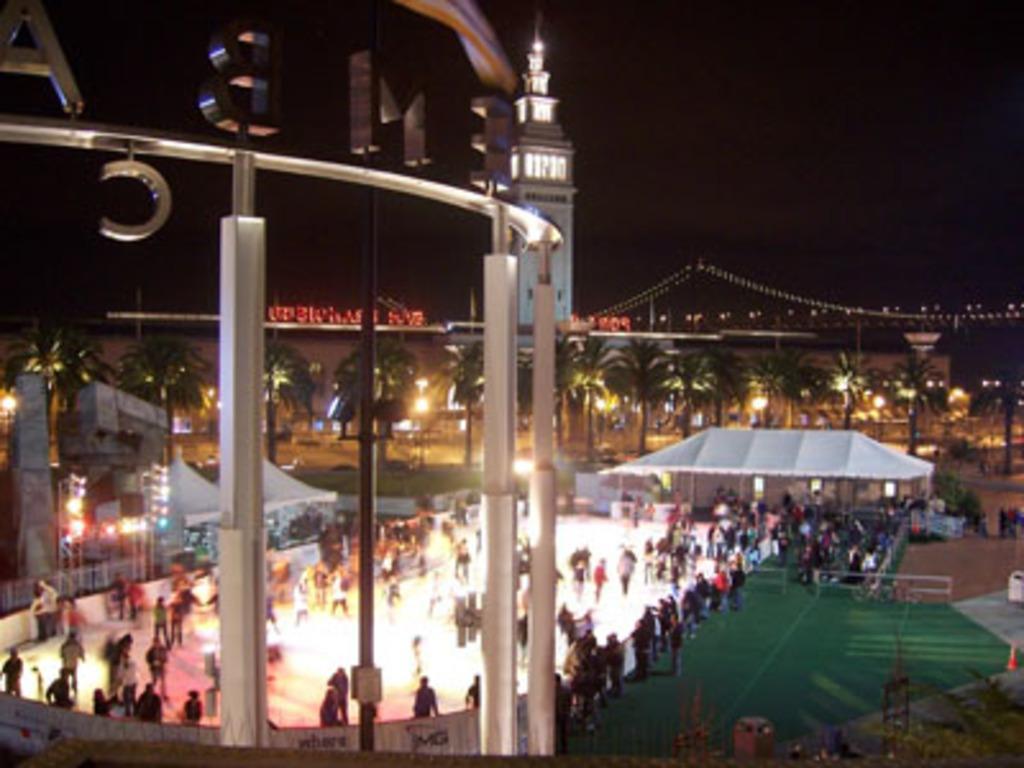Could you give a brief overview of what you see in this image? On the left side of the image there are metal rods. There are few letters. There are people standing on the floor. There are buildings, trees, lights. At the bottom of the image there is a mat. In the background of the image there is sky. 